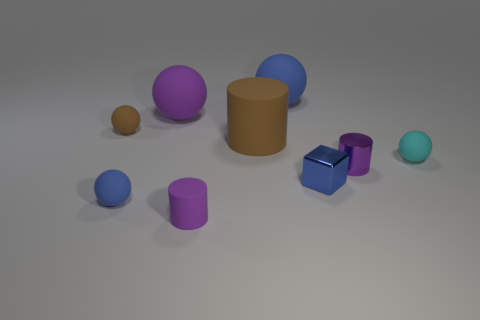Subtract all tiny rubber spheres. How many spheres are left? 2 Subtract 1 spheres. How many spheres are left? 4 Subtract all cyan balls. How many balls are left? 4 Subtract all cyan balls. Subtract all cyan cubes. How many balls are left? 4 Subtract all cubes. How many objects are left? 8 Subtract 0 cyan cubes. How many objects are left? 9 Subtract all small red metal balls. Subtract all brown things. How many objects are left? 7 Add 7 tiny brown rubber things. How many tiny brown rubber things are left? 8 Add 5 large blue metal objects. How many large blue metal objects exist? 5 